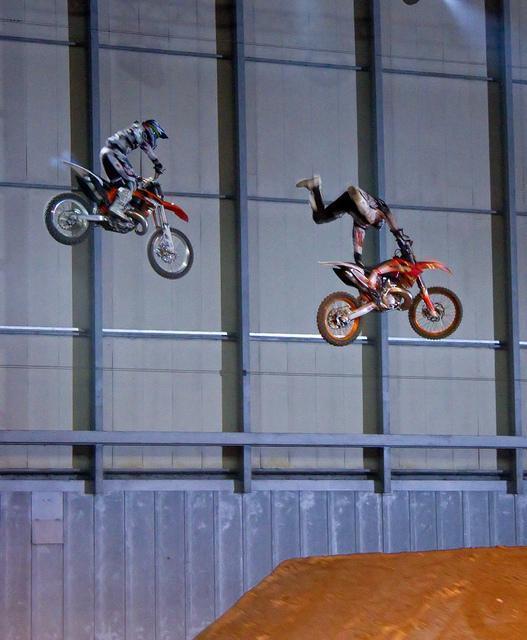What mechanism the the motorcyclists just engage?
Make your selection and explain in format: 'Answer: answer
Rationale: rationale.'
Options: Pit, ramp, flat surface, sand pit. Answer: ramp.
Rationale: The motorcycles taken off from a point. 